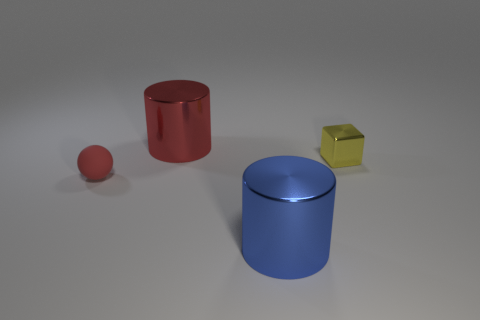The cylinder that is behind the small object on the left side of the large metal thing behind the large blue object is made of what material? The tall red cylinder positioned behind the small yellow cube, which is to the left of the larger, central blue cylinder, appears to have a metallic surface that reflects light similarly to the other objects around it, suggesting that it is indeed made of metal. 